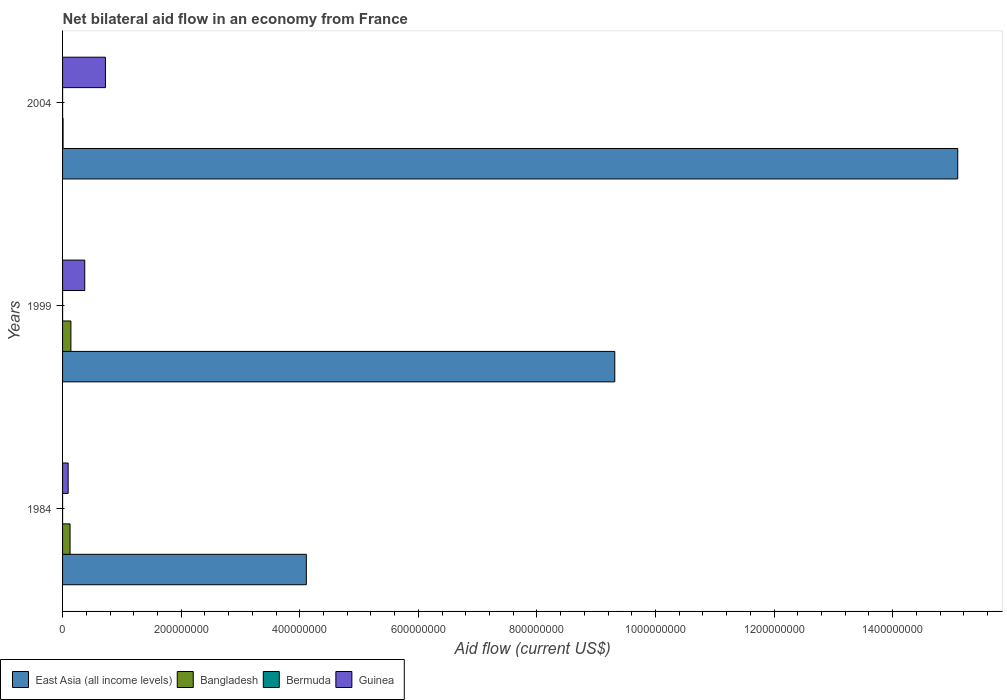How many different coloured bars are there?
Give a very brief answer. 4. How many groups of bars are there?
Your answer should be very brief. 3. Are the number of bars per tick equal to the number of legend labels?
Ensure brevity in your answer.  Yes. What is the net bilateral aid flow in Bangladesh in 1984?
Your answer should be very brief. 1.26e+07. Across all years, what is the maximum net bilateral aid flow in Bangladesh?
Your response must be concise. 1.41e+07. Across all years, what is the minimum net bilateral aid flow in Guinea?
Provide a short and direct response. 9.42e+06. In which year was the net bilateral aid flow in Guinea minimum?
Ensure brevity in your answer.  1984. What is the total net bilateral aid flow in East Asia (all income levels) in the graph?
Your answer should be very brief. 2.85e+09. What is the difference between the net bilateral aid flow in East Asia (all income levels) in 1984 and that in 2004?
Ensure brevity in your answer.  -1.10e+09. What is the difference between the net bilateral aid flow in Guinea in 2004 and the net bilateral aid flow in Bermuda in 1984?
Offer a terse response. 7.23e+07. What is the average net bilateral aid flow in Guinea per year?
Your response must be concise. 3.97e+07. In the year 1984, what is the difference between the net bilateral aid flow in Guinea and net bilateral aid flow in Bermuda?
Keep it short and to the point. 9.41e+06. What is the ratio of the net bilateral aid flow in Bangladesh in 1984 to that in 1999?
Offer a very short reply. 0.9. What is the difference between the highest and the lowest net bilateral aid flow in Bangladesh?
Your response must be concise. 1.32e+07. In how many years, is the net bilateral aid flow in Bangladesh greater than the average net bilateral aid flow in Bangladesh taken over all years?
Make the answer very short. 2. What does the 4th bar from the top in 1999 represents?
Provide a short and direct response. East Asia (all income levels). What does the 1st bar from the bottom in 1999 represents?
Keep it short and to the point. East Asia (all income levels). How many bars are there?
Your answer should be compact. 12. What is the difference between two consecutive major ticks on the X-axis?
Make the answer very short. 2.00e+08. Where does the legend appear in the graph?
Provide a succinct answer. Bottom left. How many legend labels are there?
Your answer should be compact. 4. What is the title of the graph?
Your answer should be compact. Net bilateral aid flow in an economy from France. What is the label or title of the X-axis?
Your answer should be compact. Aid flow (current US$). What is the label or title of the Y-axis?
Give a very brief answer. Years. What is the Aid flow (current US$) of East Asia (all income levels) in 1984?
Provide a short and direct response. 4.11e+08. What is the Aid flow (current US$) of Bangladesh in 1984?
Provide a short and direct response. 1.26e+07. What is the Aid flow (current US$) in Bermuda in 1984?
Give a very brief answer. 10000. What is the Aid flow (current US$) in Guinea in 1984?
Provide a short and direct response. 9.42e+06. What is the Aid flow (current US$) in East Asia (all income levels) in 1999?
Offer a very short reply. 9.31e+08. What is the Aid flow (current US$) of Bangladesh in 1999?
Provide a short and direct response. 1.41e+07. What is the Aid flow (current US$) of Bermuda in 1999?
Your answer should be very brief. 5.00e+04. What is the Aid flow (current US$) of Guinea in 1999?
Provide a short and direct response. 3.74e+07. What is the Aid flow (current US$) of East Asia (all income levels) in 2004?
Make the answer very short. 1.51e+09. What is the Aid flow (current US$) of Bangladesh in 2004?
Offer a very short reply. 8.70e+05. What is the Aid flow (current US$) of Bermuda in 2004?
Your response must be concise. 5.00e+04. What is the Aid flow (current US$) of Guinea in 2004?
Provide a short and direct response. 7.23e+07. Across all years, what is the maximum Aid flow (current US$) of East Asia (all income levels)?
Make the answer very short. 1.51e+09. Across all years, what is the maximum Aid flow (current US$) in Bangladesh?
Offer a very short reply. 1.41e+07. Across all years, what is the maximum Aid flow (current US$) of Guinea?
Provide a short and direct response. 7.23e+07. Across all years, what is the minimum Aid flow (current US$) in East Asia (all income levels)?
Ensure brevity in your answer.  4.11e+08. Across all years, what is the minimum Aid flow (current US$) of Bangladesh?
Your answer should be compact. 8.70e+05. Across all years, what is the minimum Aid flow (current US$) of Bermuda?
Keep it short and to the point. 10000. Across all years, what is the minimum Aid flow (current US$) in Guinea?
Make the answer very short. 9.42e+06. What is the total Aid flow (current US$) in East Asia (all income levels) in the graph?
Ensure brevity in your answer.  2.85e+09. What is the total Aid flow (current US$) in Bangladesh in the graph?
Offer a terse response. 2.76e+07. What is the total Aid flow (current US$) in Guinea in the graph?
Your response must be concise. 1.19e+08. What is the difference between the Aid flow (current US$) of East Asia (all income levels) in 1984 and that in 1999?
Provide a short and direct response. -5.20e+08. What is the difference between the Aid flow (current US$) of Bangladesh in 1984 and that in 1999?
Provide a short and direct response. -1.43e+06. What is the difference between the Aid flow (current US$) of Bermuda in 1984 and that in 1999?
Keep it short and to the point. -4.00e+04. What is the difference between the Aid flow (current US$) in Guinea in 1984 and that in 1999?
Keep it short and to the point. -2.80e+07. What is the difference between the Aid flow (current US$) of East Asia (all income levels) in 1984 and that in 2004?
Your response must be concise. -1.10e+09. What is the difference between the Aid flow (current US$) in Bangladesh in 1984 and that in 2004?
Give a very brief answer. 1.18e+07. What is the difference between the Aid flow (current US$) in Guinea in 1984 and that in 2004?
Your answer should be very brief. -6.29e+07. What is the difference between the Aid flow (current US$) in East Asia (all income levels) in 1999 and that in 2004?
Your answer should be compact. -5.78e+08. What is the difference between the Aid flow (current US$) of Bangladesh in 1999 and that in 2004?
Your answer should be very brief. 1.32e+07. What is the difference between the Aid flow (current US$) of Bermuda in 1999 and that in 2004?
Keep it short and to the point. 0. What is the difference between the Aid flow (current US$) in Guinea in 1999 and that in 2004?
Provide a succinct answer. -3.49e+07. What is the difference between the Aid flow (current US$) in East Asia (all income levels) in 1984 and the Aid flow (current US$) in Bangladesh in 1999?
Keep it short and to the point. 3.97e+08. What is the difference between the Aid flow (current US$) in East Asia (all income levels) in 1984 and the Aid flow (current US$) in Bermuda in 1999?
Make the answer very short. 4.11e+08. What is the difference between the Aid flow (current US$) of East Asia (all income levels) in 1984 and the Aid flow (current US$) of Guinea in 1999?
Your answer should be very brief. 3.74e+08. What is the difference between the Aid flow (current US$) of Bangladesh in 1984 and the Aid flow (current US$) of Bermuda in 1999?
Provide a succinct answer. 1.26e+07. What is the difference between the Aid flow (current US$) of Bangladesh in 1984 and the Aid flow (current US$) of Guinea in 1999?
Your response must be concise. -2.48e+07. What is the difference between the Aid flow (current US$) of Bermuda in 1984 and the Aid flow (current US$) of Guinea in 1999?
Your answer should be very brief. -3.74e+07. What is the difference between the Aid flow (current US$) in East Asia (all income levels) in 1984 and the Aid flow (current US$) in Bangladesh in 2004?
Offer a terse response. 4.10e+08. What is the difference between the Aid flow (current US$) of East Asia (all income levels) in 1984 and the Aid flow (current US$) of Bermuda in 2004?
Offer a terse response. 4.11e+08. What is the difference between the Aid flow (current US$) of East Asia (all income levels) in 1984 and the Aid flow (current US$) of Guinea in 2004?
Give a very brief answer. 3.39e+08. What is the difference between the Aid flow (current US$) in Bangladesh in 1984 and the Aid flow (current US$) in Bermuda in 2004?
Make the answer very short. 1.26e+07. What is the difference between the Aid flow (current US$) of Bangladesh in 1984 and the Aid flow (current US$) of Guinea in 2004?
Provide a short and direct response. -5.97e+07. What is the difference between the Aid flow (current US$) of Bermuda in 1984 and the Aid flow (current US$) of Guinea in 2004?
Offer a terse response. -7.23e+07. What is the difference between the Aid flow (current US$) of East Asia (all income levels) in 1999 and the Aid flow (current US$) of Bangladesh in 2004?
Make the answer very short. 9.30e+08. What is the difference between the Aid flow (current US$) of East Asia (all income levels) in 1999 and the Aid flow (current US$) of Bermuda in 2004?
Offer a very short reply. 9.31e+08. What is the difference between the Aid flow (current US$) of East Asia (all income levels) in 1999 and the Aid flow (current US$) of Guinea in 2004?
Your answer should be very brief. 8.59e+08. What is the difference between the Aid flow (current US$) of Bangladesh in 1999 and the Aid flow (current US$) of Bermuda in 2004?
Offer a terse response. 1.40e+07. What is the difference between the Aid flow (current US$) of Bangladesh in 1999 and the Aid flow (current US$) of Guinea in 2004?
Your response must be concise. -5.82e+07. What is the difference between the Aid flow (current US$) of Bermuda in 1999 and the Aid flow (current US$) of Guinea in 2004?
Offer a terse response. -7.23e+07. What is the average Aid flow (current US$) in East Asia (all income levels) per year?
Offer a terse response. 9.51e+08. What is the average Aid flow (current US$) of Bangladesh per year?
Make the answer very short. 9.19e+06. What is the average Aid flow (current US$) of Bermuda per year?
Offer a terse response. 3.67e+04. What is the average Aid flow (current US$) of Guinea per year?
Make the answer very short. 3.97e+07. In the year 1984, what is the difference between the Aid flow (current US$) in East Asia (all income levels) and Aid flow (current US$) in Bangladesh?
Ensure brevity in your answer.  3.98e+08. In the year 1984, what is the difference between the Aid flow (current US$) of East Asia (all income levels) and Aid flow (current US$) of Bermuda?
Your response must be concise. 4.11e+08. In the year 1984, what is the difference between the Aid flow (current US$) in East Asia (all income levels) and Aid flow (current US$) in Guinea?
Ensure brevity in your answer.  4.02e+08. In the year 1984, what is the difference between the Aid flow (current US$) of Bangladesh and Aid flow (current US$) of Bermuda?
Your answer should be compact. 1.26e+07. In the year 1984, what is the difference between the Aid flow (current US$) of Bangladesh and Aid flow (current US$) of Guinea?
Your answer should be compact. 3.22e+06. In the year 1984, what is the difference between the Aid flow (current US$) of Bermuda and Aid flow (current US$) of Guinea?
Offer a terse response. -9.41e+06. In the year 1999, what is the difference between the Aid flow (current US$) in East Asia (all income levels) and Aid flow (current US$) in Bangladesh?
Your response must be concise. 9.17e+08. In the year 1999, what is the difference between the Aid flow (current US$) of East Asia (all income levels) and Aid flow (current US$) of Bermuda?
Provide a succinct answer. 9.31e+08. In the year 1999, what is the difference between the Aid flow (current US$) in East Asia (all income levels) and Aid flow (current US$) in Guinea?
Give a very brief answer. 8.94e+08. In the year 1999, what is the difference between the Aid flow (current US$) of Bangladesh and Aid flow (current US$) of Bermuda?
Your response must be concise. 1.40e+07. In the year 1999, what is the difference between the Aid flow (current US$) of Bangladesh and Aid flow (current US$) of Guinea?
Provide a short and direct response. -2.34e+07. In the year 1999, what is the difference between the Aid flow (current US$) of Bermuda and Aid flow (current US$) of Guinea?
Give a very brief answer. -3.74e+07. In the year 2004, what is the difference between the Aid flow (current US$) of East Asia (all income levels) and Aid flow (current US$) of Bangladesh?
Your answer should be compact. 1.51e+09. In the year 2004, what is the difference between the Aid flow (current US$) in East Asia (all income levels) and Aid flow (current US$) in Bermuda?
Offer a terse response. 1.51e+09. In the year 2004, what is the difference between the Aid flow (current US$) of East Asia (all income levels) and Aid flow (current US$) of Guinea?
Your answer should be very brief. 1.44e+09. In the year 2004, what is the difference between the Aid flow (current US$) in Bangladesh and Aid flow (current US$) in Bermuda?
Provide a short and direct response. 8.20e+05. In the year 2004, what is the difference between the Aid flow (current US$) of Bangladesh and Aid flow (current US$) of Guinea?
Provide a succinct answer. -7.14e+07. In the year 2004, what is the difference between the Aid flow (current US$) in Bermuda and Aid flow (current US$) in Guinea?
Offer a terse response. -7.23e+07. What is the ratio of the Aid flow (current US$) of East Asia (all income levels) in 1984 to that in 1999?
Your answer should be very brief. 0.44. What is the ratio of the Aid flow (current US$) of Bangladesh in 1984 to that in 1999?
Offer a terse response. 0.9. What is the ratio of the Aid flow (current US$) in Guinea in 1984 to that in 1999?
Offer a very short reply. 0.25. What is the ratio of the Aid flow (current US$) in East Asia (all income levels) in 1984 to that in 2004?
Your response must be concise. 0.27. What is the ratio of the Aid flow (current US$) of Bangladesh in 1984 to that in 2004?
Keep it short and to the point. 14.53. What is the ratio of the Aid flow (current US$) of Bermuda in 1984 to that in 2004?
Your answer should be compact. 0.2. What is the ratio of the Aid flow (current US$) of Guinea in 1984 to that in 2004?
Your response must be concise. 0.13. What is the ratio of the Aid flow (current US$) in East Asia (all income levels) in 1999 to that in 2004?
Provide a succinct answer. 0.62. What is the ratio of the Aid flow (current US$) in Bangladesh in 1999 to that in 2004?
Your answer should be compact. 16.17. What is the ratio of the Aid flow (current US$) in Bermuda in 1999 to that in 2004?
Your answer should be very brief. 1. What is the ratio of the Aid flow (current US$) in Guinea in 1999 to that in 2004?
Offer a terse response. 0.52. What is the difference between the highest and the second highest Aid flow (current US$) of East Asia (all income levels)?
Your answer should be very brief. 5.78e+08. What is the difference between the highest and the second highest Aid flow (current US$) in Bangladesh?
Offer a very short reply. 1.43e+06. What is the difference between the highest and the second highest Aid flow (current US$) of Guinea?
Your answer should be compact. 3.49e+07. What is the difference between the highest and the lowest Aid flow (current US$) in East Asia (all income levels)?
Your answer should be compact. 1.10e+09. What is the difference between the highest and the lowest Aid flow (current US$) of Bangladesh?
Provide a short and direct response. 1.32e+07. What is the difference between the highest and the lowest Aid flow (current US$) of Guinea?
Provide a short and direct response. 6.29e+07. 